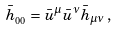<formula> <loc_0><loc_0><loc_500><loc_500>\bar { h } _ { _ { 0 0 } } = \bar { u } ^ { \mu } \bar { u } ^ { \nu } \bar { h } _ { \mu \nu } \, ,</formula> 